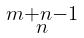Convert formula to latex. <formula><loc_0><loc_0><loc_500><loc_500>\begin{smallmatrix} m + n - 1 \\ n \end{smallmatrix}</formula> 